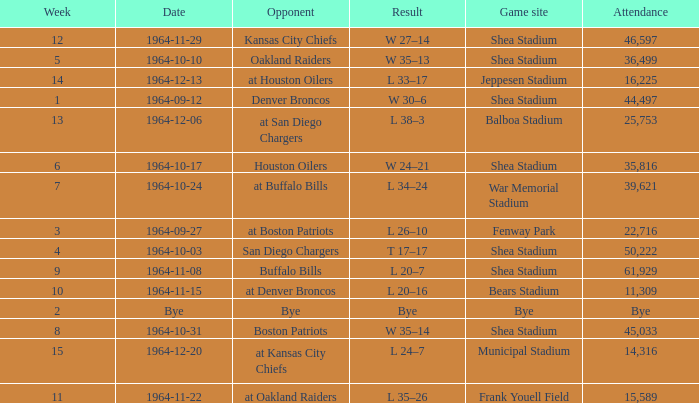Where did the Jet's play with an attendance of 11,309? Bears Stadium. 